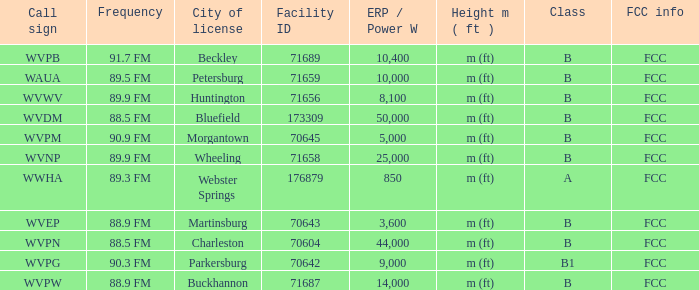What city has the A Class licence? Webster Springs. 